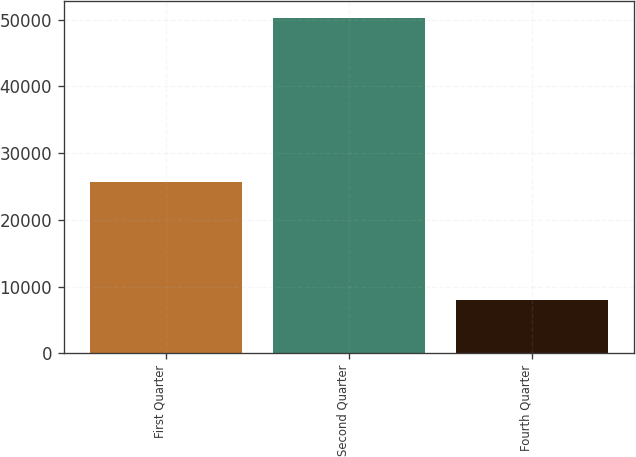<chart> <loc_0><loc_0><loc_500><loc_500><bar_chart><fcel>First Quarter<fcel>Second Quarter<fcel>Fourth Quarter<nl><fcel>25608<fcel>50298<fcel>8040<nl></chart> 